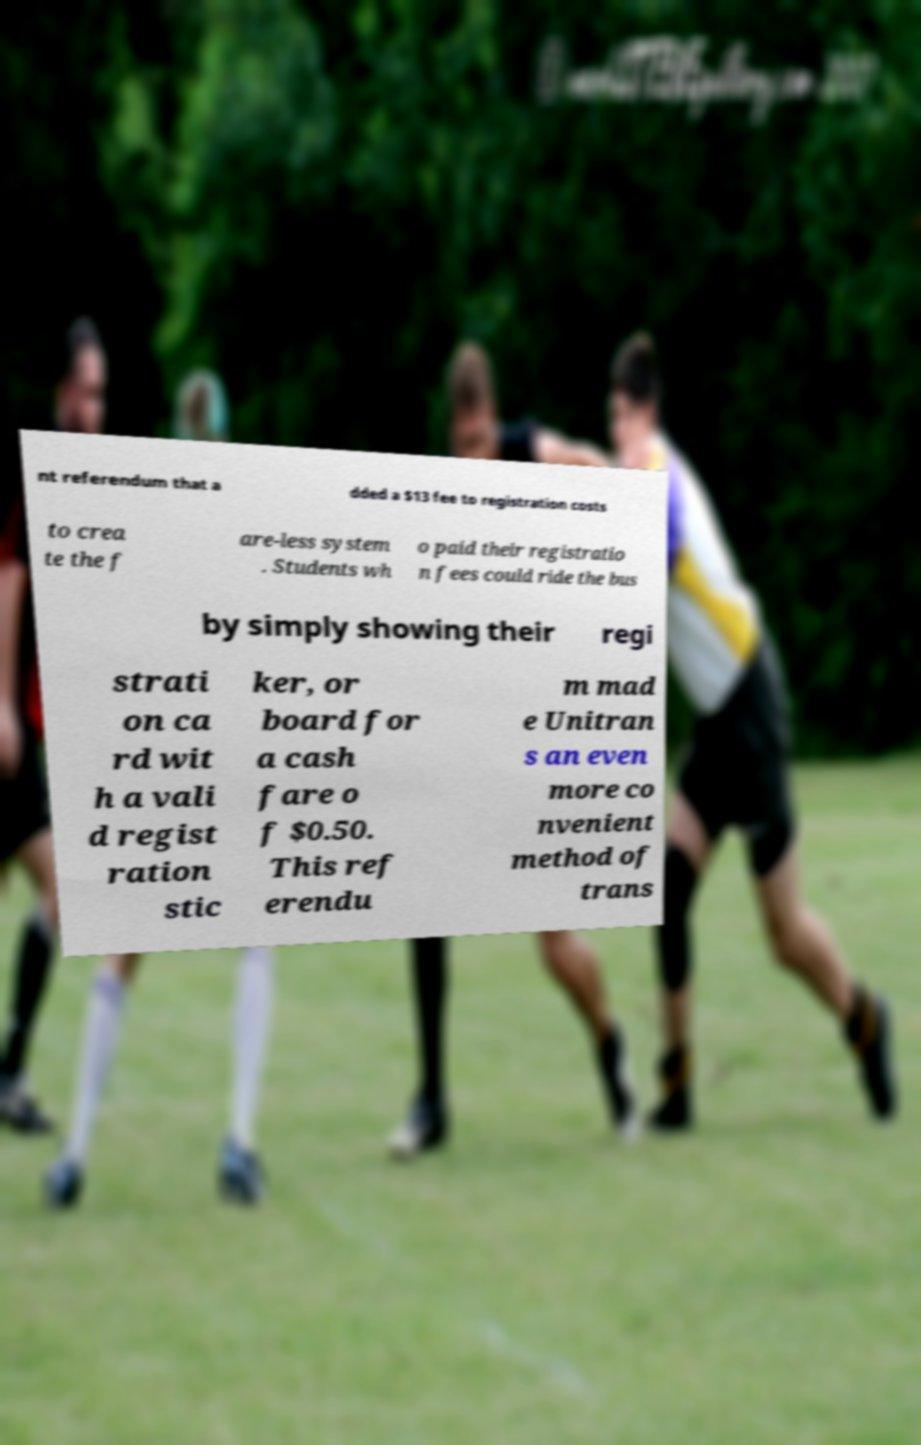Can you read and provide the text displayed in the image?This photo seems to have some interesting text. Can you extract and type it out for me? nt referendum that a dded a $13 fee to registration costs to crea te the f are-less system . Students wh o paid their registratio n fees could ride the bus by simply showing their regi strati on ca rd wit h a vali d regist ration stic ker, or board for a cash fare o f $0.50. This ref erendu m mad e Unitran s an even more co nvenient method of trans 